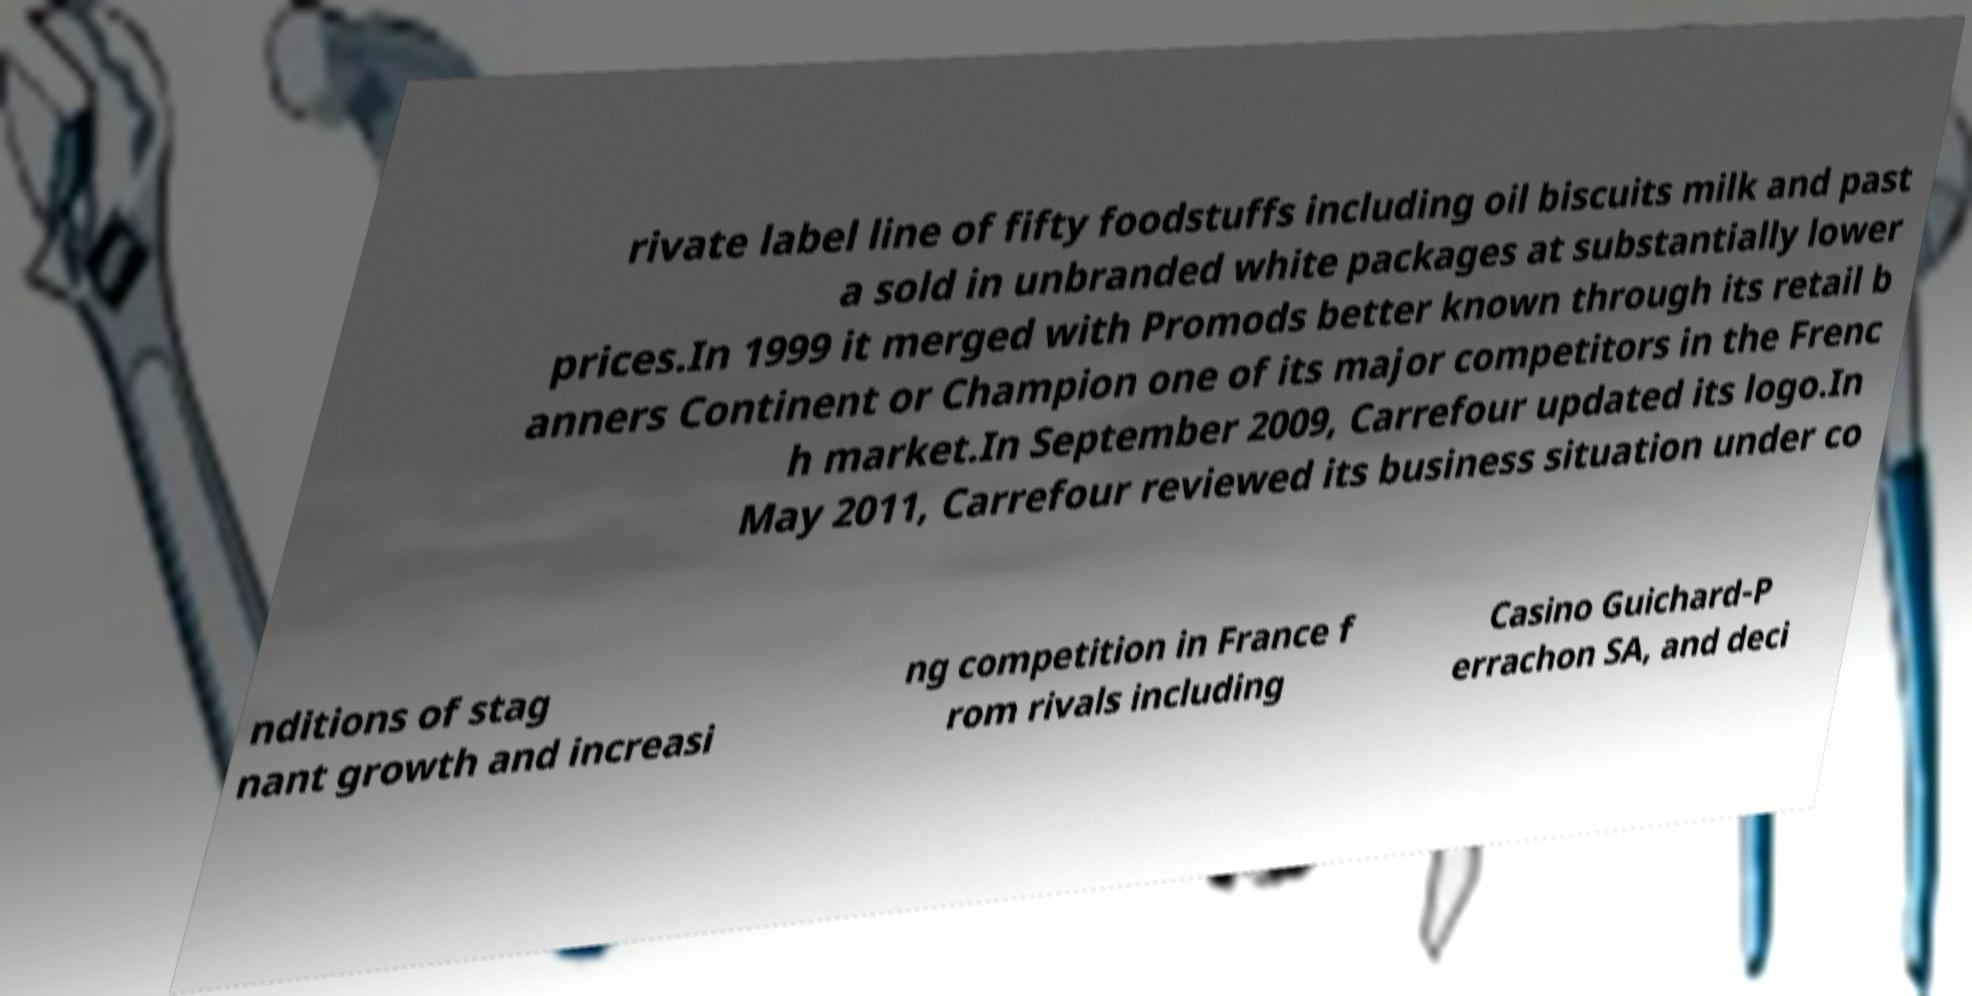Please read and relay the text visible in this image. What does it say? rivate label line of fifty foodstuffs including oil biscuits milk and past a sold in unbranded white packages at substantially lower prices.In 1999 it merged with Promods better known through its retail b anners Continent or Champion one of its major competitors in the Frenc h market.In September 2009, Carrefour updated its logo.In May 2011, Carrefour reviewed its business situation under co nditions of stag nant growth and increasi ng competition in France f rom rivals including Casino Guichard-P errachon SA, and deci 